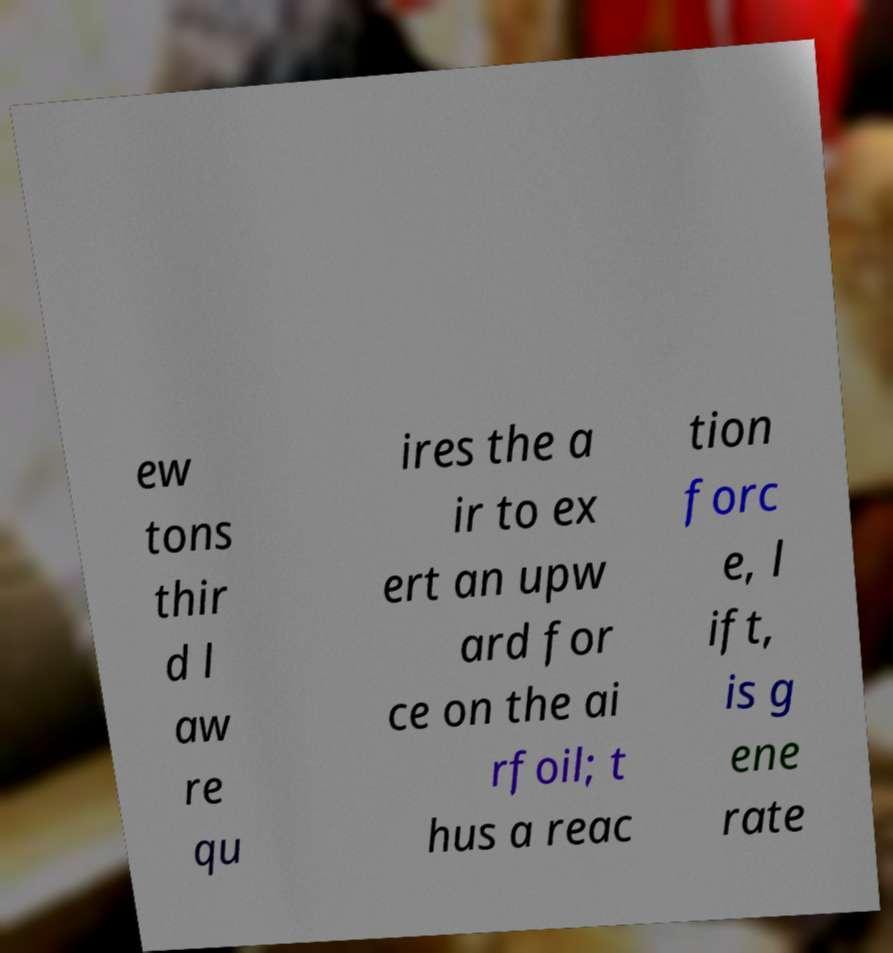I need the written content from this picture converted into text. Can you do that? ew tons thir d l aw re qu ires the a ir to ex ert an upw ard for ce on the ai rfoil; t hus a reac tion forc e, l ift, is g ene rate 